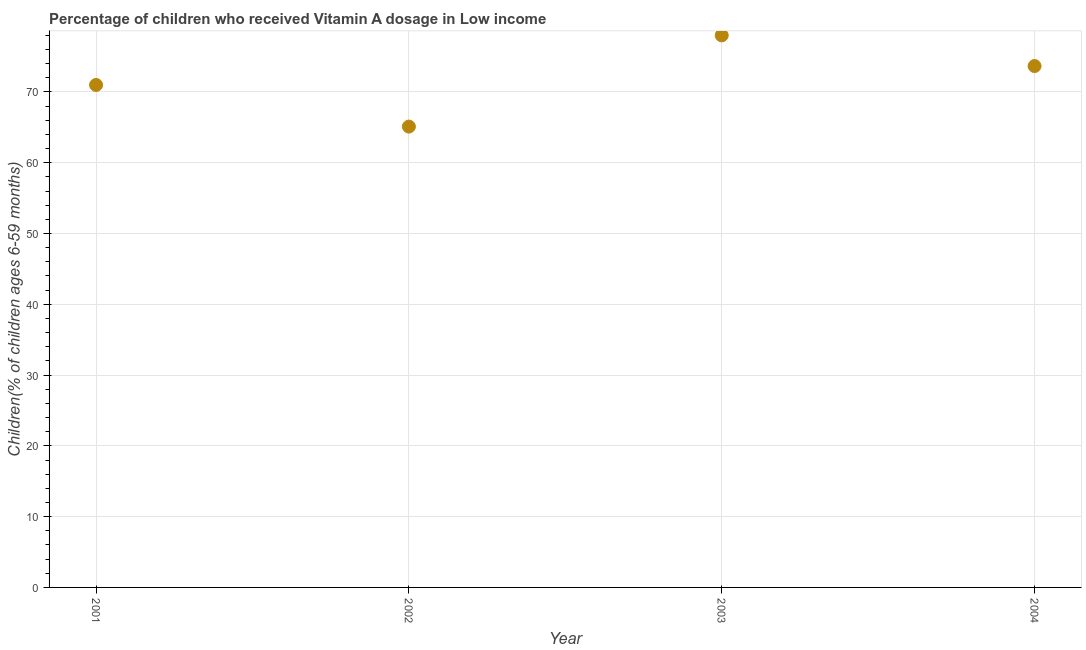What is the vitamin a supplementation coverage rate in 2002?
Offer a terse response. 65.1. Across all years, what is the maximum vitamin a supplementation coverage rate?
Offer a terse response. 77.99. Across all years, what is the minimum vitamin a supplementation coverage rate?
Offer a very short reply. 65.1. In which year was the vitamin a supplementation coverage rate maximum?
Keep it short and to the point. 2003. What is the sum of the vitamin a supplementation coverage rate?
Provide a succinct answer. 287.73. What is the difference between the vitamin a supplementation coverage rate in 2002 and 2003?
Your answer should be compact. -12.88. What is the average vitamin a supplementation coverage rate per year?
Offer a very short reply. 71.93. What is the median vitamin a supplementation coverage rate?
Offer a terse response. 72.32. In how many years, is the vitamin a supplementation coverage rate greater than 6 %?
Your response must be concise. 4. Do a majority of the years between 2001 and 2003 (inclusive) have vitamin a supplementation coverage rate greater than 16 %?
Keep it short and to the point. Yes. What is the ratio of the vitamin a supplementation coverage rate in 2001 to that in 2002?
Provide a succinct answer. 1.09. What is the difference between the highest and the second highest vitamin a supplementation coverage rate?
Your answer should be compact. 4.33. What is the difference between the highest and the lowest vitamin a supplementation coverage rate?
Make the answer very short. 12.88. In how many years, is the vitamin a supplementation coverage rate greater than the average vitamin a supplementation coverage rate taken over all years?
Your answer should be very brief. 2. How many dotlines are there?
Your answer should be very brief. 1. How many years are there in the graph?
Your response must be concise. 4. What is the difference between two consecutive major ticks on the Y-axis?
Ensure brevity in your answer.  10. Are the values on the major ticks of Y-axis written in scientific E-notation?
Ensure brevity in your answer.  No. Does the graph contain any zero values?
Your answer should be compact. No. What is the title of the graph?
Keep it short and to the point. Percentage of children who received Vitamin A dosage in Low income. What is the label or title of the X-axis?
Offer a terse response. Year. What is the label or title of the Y-axis?
Your answer should be compact. Children(% of children ages 6-59 months). What is the Children(% of children ages 6-59 months) in 2001?
Provide a short and direct response. 70.98. What is the Children(% of children ages 6-59 months) in 2002?
Your response must be concise. 65.1. What is the Children(% of children ages 6-59 months) in 2003?
Your answer should be compact. 77.99. What is the Children(% of children ages 6-59 months) in 2004?
Your answer should be very brief. 73.66. What is the difference between the Children(% of children ages 6-59 months) in 2001 and 2002?
Offer a very short reply. 5.88. What is the difference between the Children(% of children ages 6-59 months) in 2001 and 2003?
Offer a terse response. -7. What is the difference between the Children(% of children ages 6-59 months) in 2001 and 2004?
Your answer should be very brief. -2.67. What is the difference between the Children(% of children ages 6-59 months) in 2002 and 2003?
Provide a short and direct response. -12.88. What is the difference between the Children(% of children ages 6-59 months) in 2002 and 2004?
Make the answer very short. -8.55. What is the difference between the Children(% of children ages 6-59 months) in 2003 and 2004?
Provide a short and direct response. 4.33. What is the ratio of the Children(% of children ages 6-59 months) in 2001 to that in 2002?
Your response must be concise. 1.09. What is the ratio of the Children(% of children ages 6-59 months) in 2001 to that in 2003?
Give a very brief answer. 0.91. What is the ratio of the Children(% of children ages 6-59 months) in 2002 to that in 2003?
Offer a very short reply. 0.83. What is the ratio of the Children(% of children ages 6-59 months) in 2002 to that in 2004?
Make the answer very short. 0.88. What is the ratio of the Children(% of children ages 6-59 months) in 2003 to that in 2004?
Offer a terse response. 1.06. 